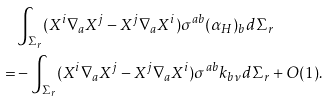Convert formula to latex. <formula><loc_0><loc_0><loc_500><loc_500>& \int _ { \Sigma _ { r } } ( X ^ { i } \nabla _ { a } X ^ { j } - X ^ { j } \nabla _ { a } X ^ { i } ) \sigma ^ { a b } ( \alpha _ { H } ) _ { b } d \Sigma _ { r } \\ = & - \int _ { \Sigma _ { r } } ( X ^ { i } \nabla _ { a } X ^ { j } - X ^ { j } \nabla _ { a } X ^ { i } ) \sigma ^ { a b } k _ { b \nu } d \Sigma _ { r } + O ( 1 ) .</formula> 